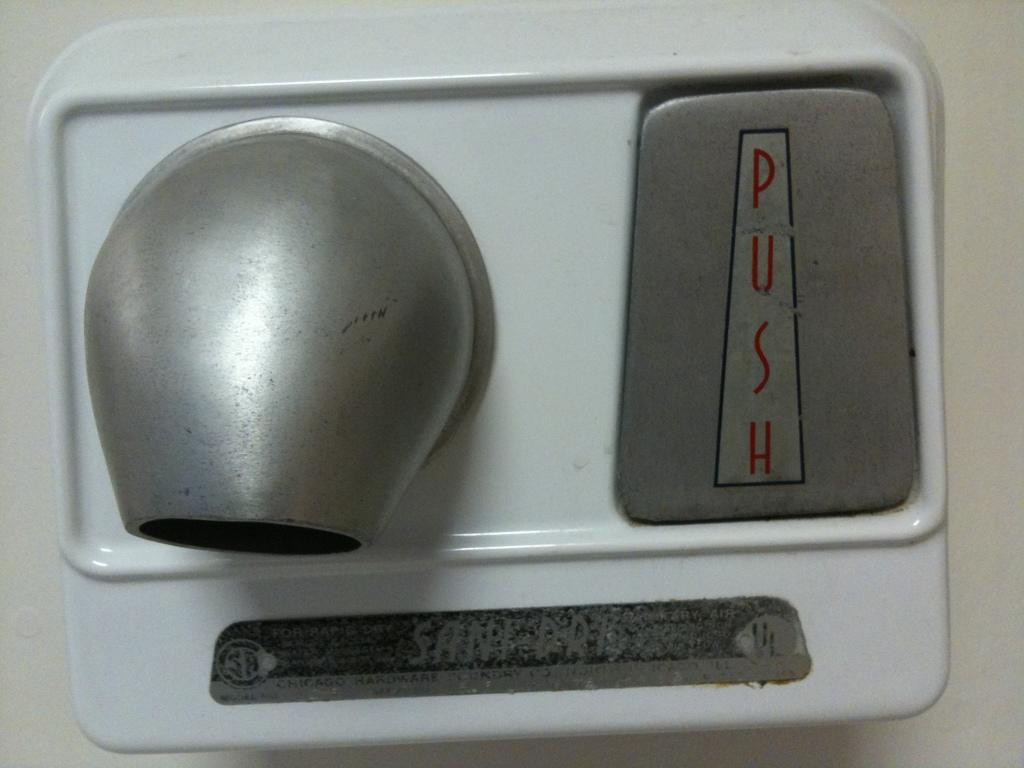Provide a one-sentence caption for the provided image. A hand dryer, labelled Sani Dry, has a button that says "push" on it. 